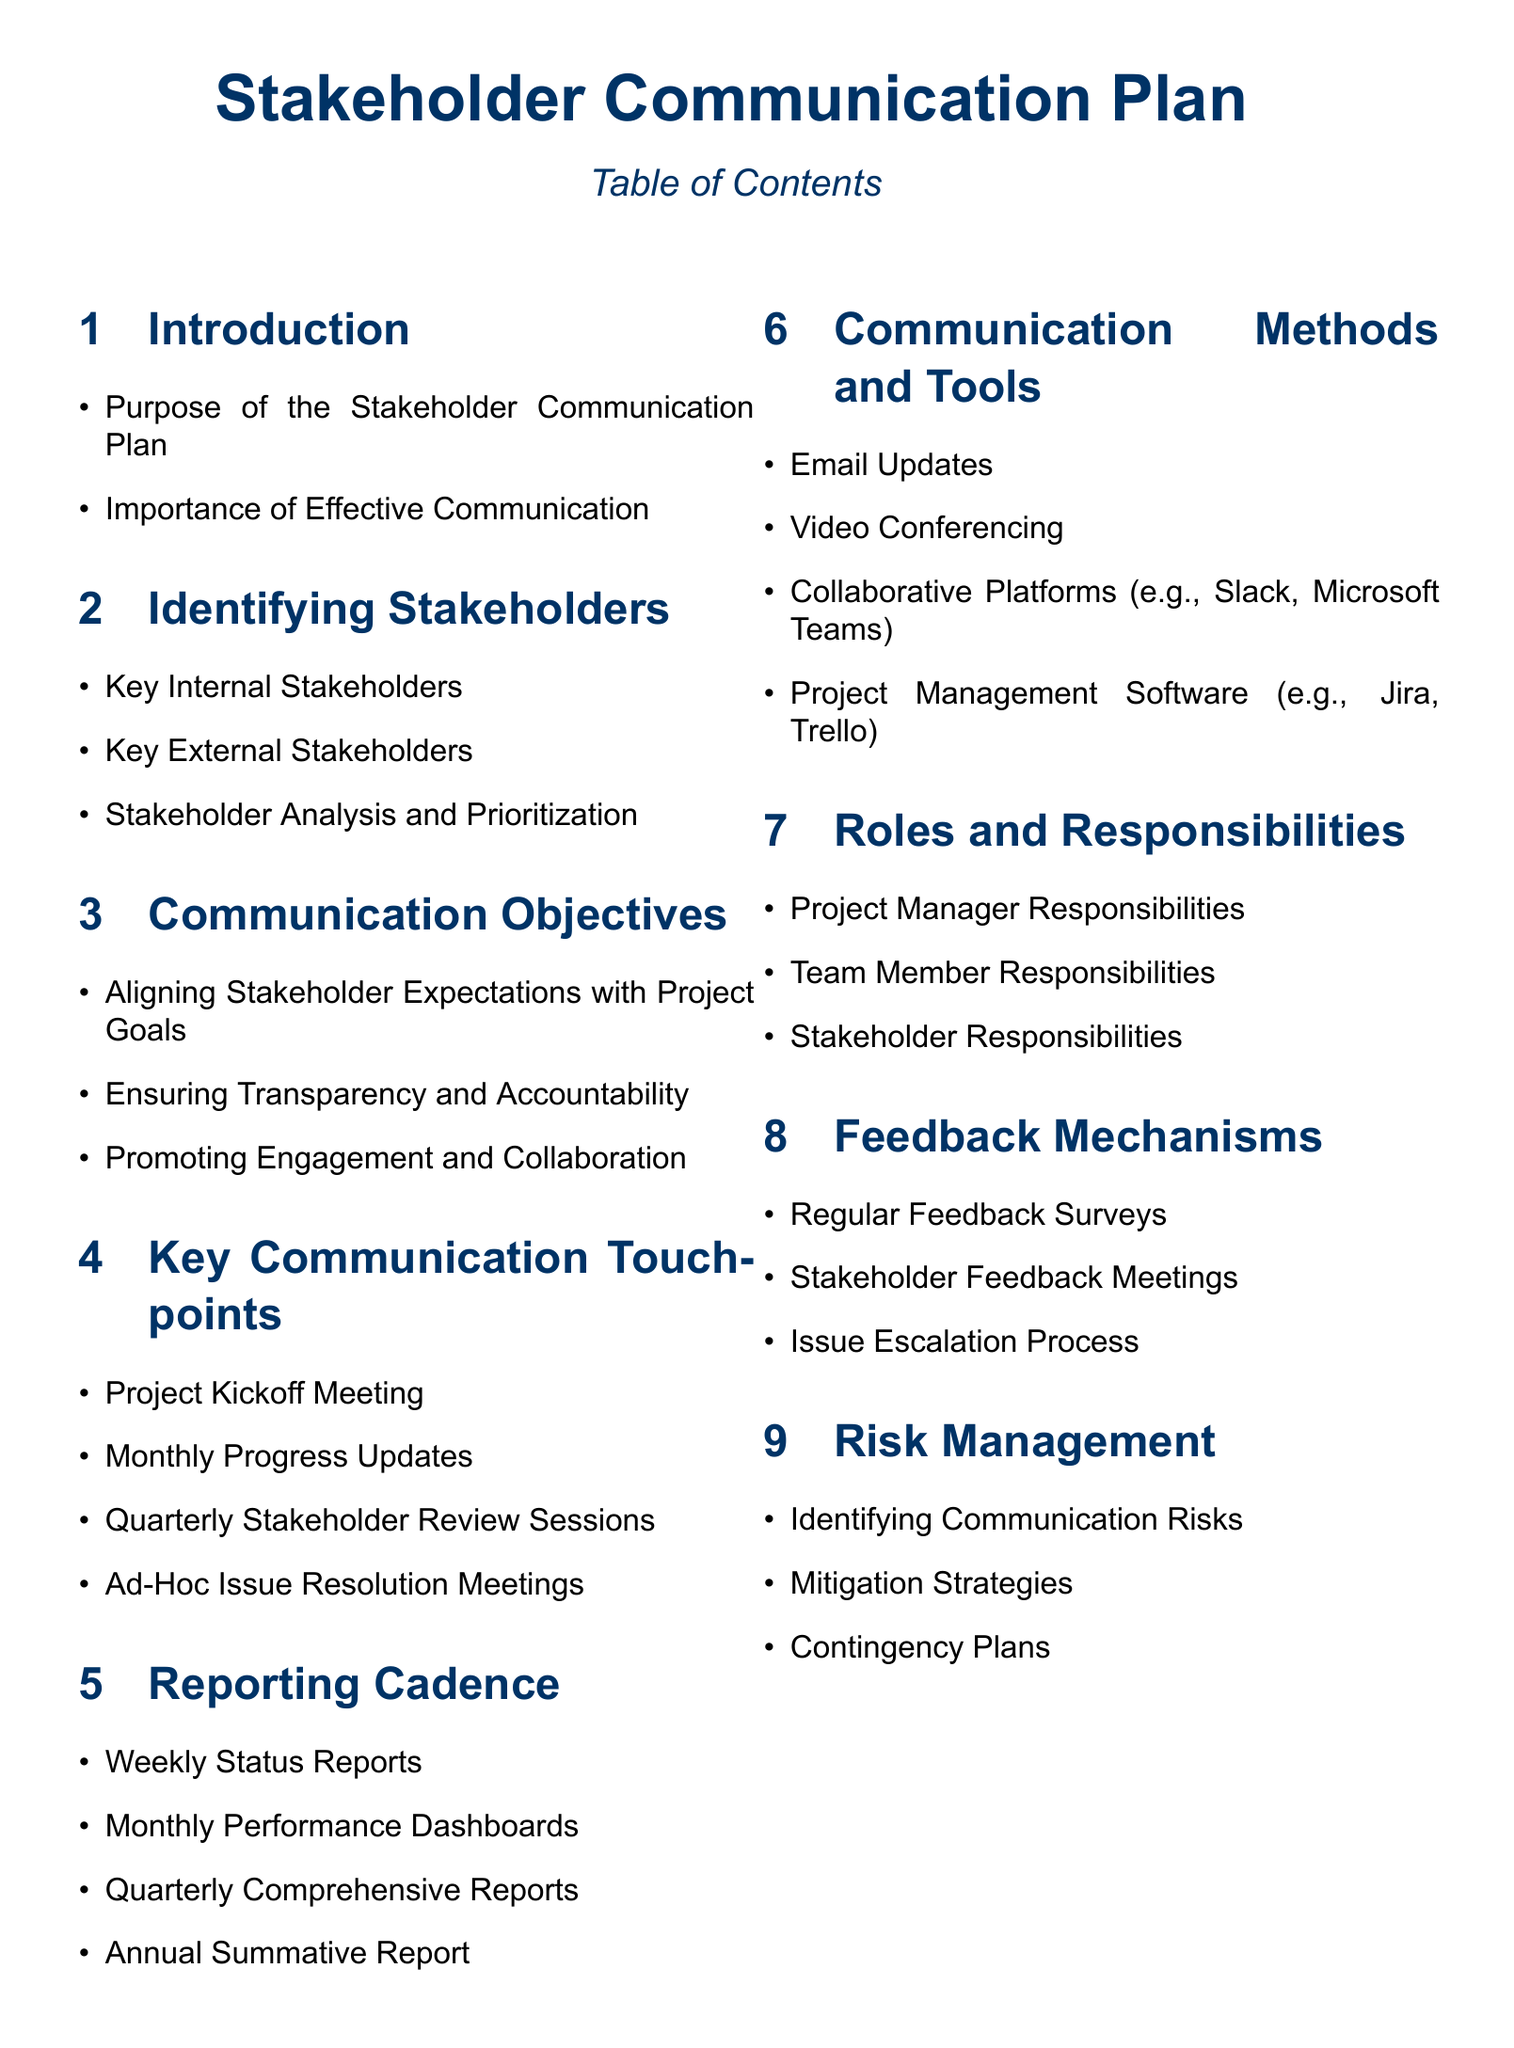What is the purpose of the Stakeholder Communication Plan? The purpose is outlined in the introduction section of the document.
Answer: Purpose of the Stakeholder Communication Plan Who are considered key external stakeholders? This information is found in the section on identifying stakeholders.
Answer: Key External Stakeholders What is one objective of communication outlined in the document? The communication objectives include aligning stakeholder expectations with project goals.
Answer: Aligning Stakeholder Expectations with Project Goals How often are quarterly comprehensive reports issued? This is mentioned under the reporting cadence section.
Answer: Quarterly What is one communication method listed in the document? The document specifies various communication methods under the communication methods and tools section.
Answer: Email Updates What feedback mechanism is mentioned in the document? The feedback mechanisms available are found in the corresponding section of the document.
Answer: Regular Feedback Surveys Who is responsible for project management? This responsibility is detailed in the roles and responsibilities section.
Answer: Project Manager Responsibilities What is a type of meeting included in the key communication touchpoints? The key communication touchpoints section lists various meetings for stakeholder communication.
Answer: Project Kickoff Meeting What is a risk management strategy mentioned in the document? Strategies are included within the risk management section.
Answer: Mitigation Strategies 